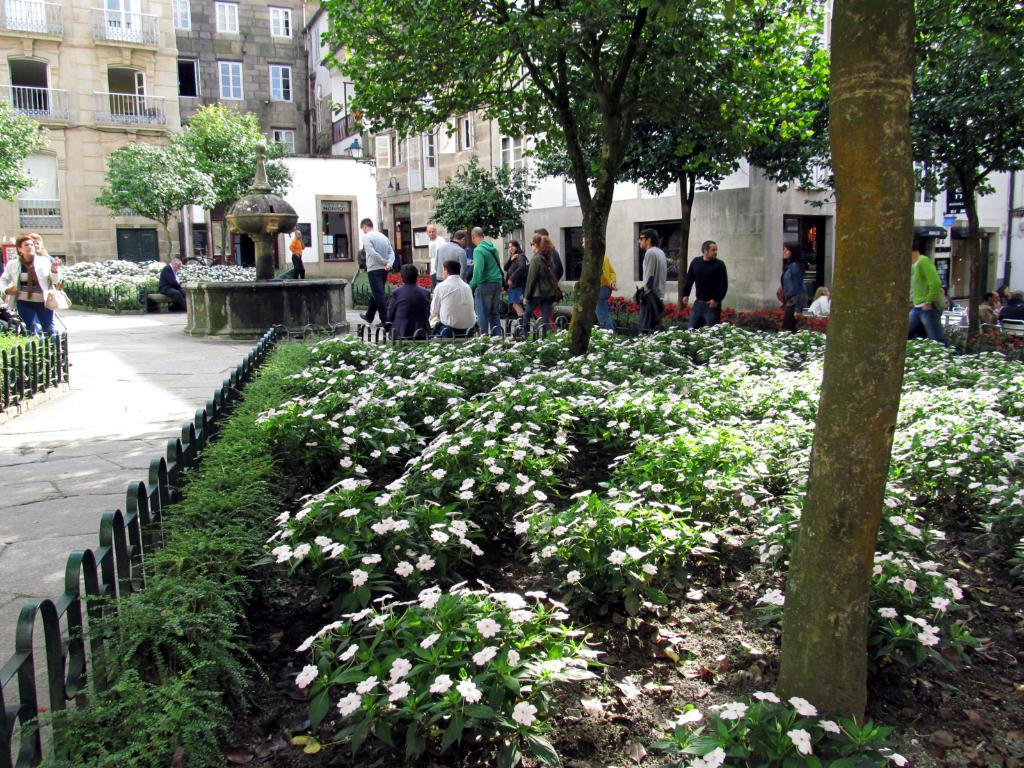What type of structures can be seen in the image? There are buildings in the image. What architectural features can be observed on the buildings? Windows are visible in the image. What type of natural elements are present in the image? There are trees in the image. What are the people in the image doing? There are people sitting and walking in the image. What type of flora is present in the image? There are white color flowers in the image. What type of barrier can be seen in the image? There is fencing in the image. How many sisters are sitting together in the image? There is no mention of sisters in the image, so we cannot determine the number of sisters present. What type of division can be seen between the buildings in the image? There is no mention of any divisions between the buildings in the image. 